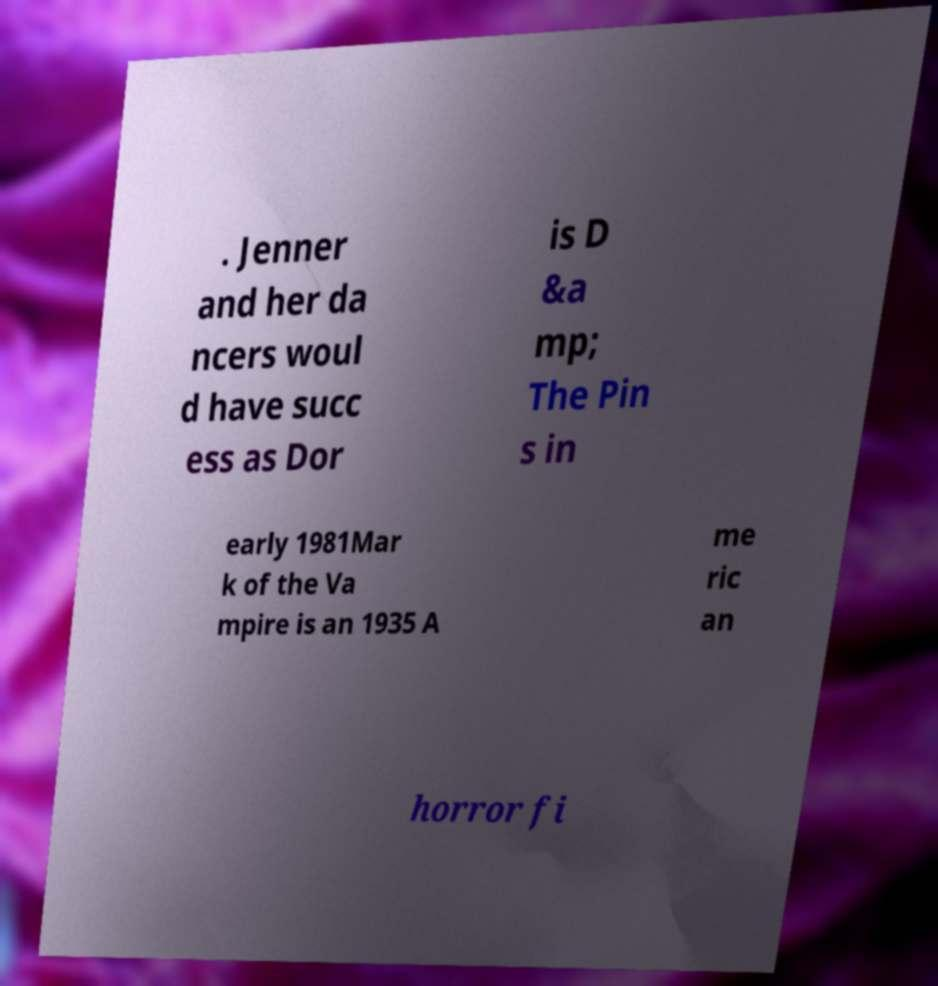Could you assist in decoding the text presented in this image and type it out clearly? . Jenner and her da ncers woul d have succ ess as Dor is D &a mp; The Pin s in early 1981Mar k of the Va mpire is an 1935 A me ric an horror fi 